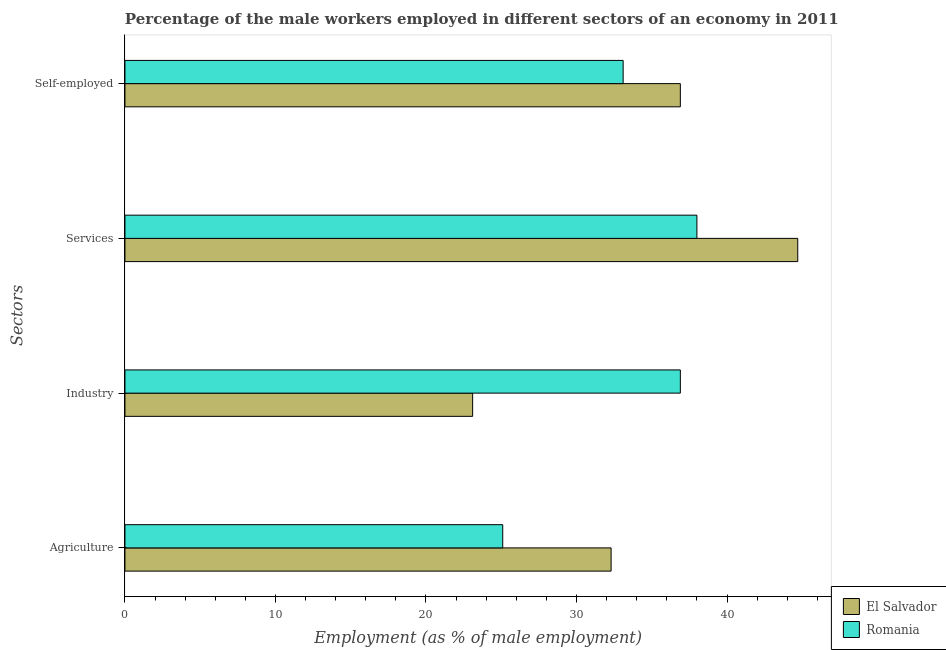How many different coloured bars are there?
Keep it short and to the point. 2. Are the number of bars on each tick of the Y-axis equal?
Give a very brief answer. Yes. How many bars are there on the 4th tick from the top?
Your answer should be very brief. 2. How many bars are there on the 4th tick from the bottom?
Ensure brevity in your answer.  2. What is the label of the 4th group of bars from the top?
Your answer should be very brief. Agriculture. What is the percentage of self employed male workers in Romania?
Ensure brevity in your answer.  33.1. Across all countries, what is the maximum percentage of male workers in agriculture?
Provide a short and direct response. 32.3. In which country was the percentage of male workers in services maximum?
Make the answer very short. El Salvador. In which country was the percentage of male workers in industry minimum?
Your answer should be compact. El Salvador. What is the total percentage of self employed male workers in the graph?
Your response must be concise. 70. What is the difference between the percentage of male workers in industry in Romania and that in El Salvador?
Ensure brevity in your answer.  13.8. What is the difference between the percentage of male workers in agriculture in El Salvador and the percentage of self employed male workers in Romania?
Keep it short and to the point. -0.8. What is the average percentage of male workers in industry per country?
Offer a very short reply. 30. What is the difference between the percentage of male workers in agriculture and percentage of male workers in industry in Romania?
Keep it short and to the point. -11.8. In how many countries, is the percentage of male workers in agriculture greater than 22 %?
Give a very brief answer. 2. What is the ratio of the percentage of male workers in agriculture in El Salvador to that in Romania?
Provide a short and direct response. 1.29. Is the percentage of self employed male workers in El Salvador less than that in Romania?
Give a very brief answer. No. What is the difference between the highest and the second highest percentage of male workers in services?
Keep it short and to the point. 6.7. What is the difference between the highest and the lowest percentage of self employed male workers?
Provide a succinct answer. 3.8. In how many countries, is the percentage of male workers in industry greater than the average percentage of male workers in industry taken over all countries?
Ensure brevity in your answer.  1. Is it the case that in every country, the sum of the percentage of male workers in services and percentage of male workers in industry is greater than the sum of percentage of male workers in agriculture and percentage of self employed male workers?
Provide a short and direct response. No. What does the 1st bar from the top in Agriculture represents?
Give a very brief answer. Romania. What does the 2nd bar from the bottom in Agriculture represents?
Ensure brevity in your answer.  Romania. Is it the case that in every country, the sum of the percentage of male workers in agriculture and percentage of male workers in industry is greater than the percentage of male workers in services?
Keep it short and to the point. Yes. How many countries are there in the graph?
Offer a terse response. 2. Are the values on the major ticks of X-axis written in scientific E-notation?
Your answer should be very brief. No. How many legend labels are there?
Offer a very short reply. 2. How are the legend labels stacked?
Provide a succinct answer. Vertical. What is the title of the graph?
Give a very brief answer. Percentage of the male workers employed in different sectors of an economy in 2011. What is the label or title of the X-axis?
Provide a short and direct response. Employment (as % of male employment). What is the label or title of the Y-axis?
Offer a terse response. Sectors. What is the Employment (as % of male employment) in El Salvador in Agriculture?
Provide a short and direct response. 32.3. What is the Employment (as % of male employment) in Romania in Agriculture?
Offer a terse response. 25.1. What is the Employment (as % of male employment) of El Salvador in Industry?
Keep it short and to the point. 23.1. What is the Employment (as % of male employment) of Romania in Industry?
Your answer should be compact. 36.9. What is the Employment (as % of male employment) of El Salvador in Services?
Offer a terse response. 44.7. What is the Employment (as % of male employment) in Romania in Services?
Keep it short and to the point. 38. What is the Employment (as % of male employment) in El Salvador in Self-employed?
Offer a terse response. 36.9. What is the Employment (as % of male employment) in Romania in Self-employed?
Offer a terse response. 33.1. Across all Sectors, what is the maximum Employment (as % of male employment) of El Salvador?
Your response must be concise. 44.7. Across all Sectors, what is the minimum Employment (as % of male employment) in El Salvador?
Your answer should be compact. 23.1. Across all Sectors, what is the minimum Employment (as % of male employment) in Romania?
Keep it short and to the point. 25.1. What is the total Employment (as % of male employment) of El Salvador in the graph?
Offer a very short reply. 137. What is the total Employment (as % of male employment) in Romania in the graph?
Give a very brief answer. 133.1. What is the difference between the Employment (as % of male employment) in Romania in Agriculture and that in Industry?
Provide a succinct answer. -11.8. What is the difference between the Employment (as % of male employment) of El Salvador in Industry and that in Services?
Your response must be concise. -21.6. What is the difference between the Employment (as % of male employment) in Romania in Services and that in Self-employed?
Give a very brief answer. 4.9. What is the difference between the Employment (as % of male employment) in El Salvador in Agriculture and the Employment (as % of male employment) in Romania in Services?
Provide a succinct answer. -5.7. What is the difference between the Employment (as % of male employment) of El Salvador in Industry and the Employment (as % of male employment) of Romania in Services?
Your answer should be very brief. -14.9. What is the average Employment (as % of male employment) of El Salvador per Sectors?
Provide a succinct answer. 34.25. What is the average Employment (as % of male employment) of Romania per Sectors?
Provide a short and direct response. 33.27. What is the difference between the Employment (as % of male employment) in El Salvador and Employment (as % of male employment) in Romania in Industry?
Keep it short and to the point. -13.8. What is the ratio of the Employment (as % of male employment) of El Salvador in Agriculture to that in Industry?
Provide a short and direct response. 1.4. What is the ratio of the Employment (as % of male employment) of Romania in Agriculture to that in Industry?
Offer a terse response. 0.68. What is the ratio of the Employment (as % of male employment) of El Salvador in Agriculture to that in Services?
Provide a succinct answer. 0.72. What is the ratio of the Employment (as % of male employment) in Romania in Agriculture to that in Services?
Your answer should be compact. 0.66. What is the ratio of the Employment (as % of male employment) of El Salvador in Agriculture to that in Self-employed?
Your answer should be very brief. 0.88. What is the ratio of the Employment (as % of male employment) in Romania in Agriculture to that in Self-employed?
Ensure brevity in your answer.  0.76. What is the ratio of the Employment (as % of male employment) of El Salvador in Industry to that in Services?
Your response must be concise. 0.52. What is the ratio of the Employment (as % of male employment) in Romania in Industry to that in Services?
Ensure brevity in your answer.  0.97. What is the ratio of the Employment (as % of male employment) in El Salvador in Industry to that in Self-employed?
Give a very brief answer. 0.63. What is the ratio of the Employment (as % of male employment) in Romania in Industry to that in Self-employed?
Your answer should be very brief. 1.11. What is the ratio of the Employment (as % of male employment) of El Salvador in Services to that in Self-employed?
Ensure brevity in your answer.  1.21. What is the ratio of the Employment (as % of male employment) in Romania in Services to that in Self-employed?
Ensure brevity in your answer.  1.15. What is the difference between the highest and the lowest Employment (as % of male employment) in El Salvador?
Ensure brevity in your answer.  21.6. What is the difference between the highest and the lowest Employment (as % of male employment) in Romania?
Your answer should be compact. 12.9. 